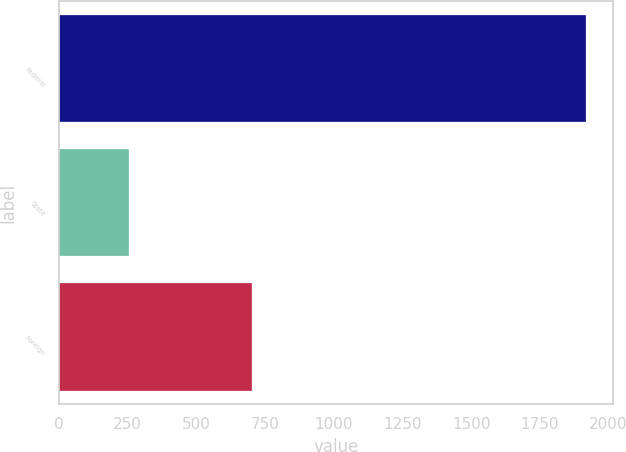Convert chart to OTSL. <chart><loc_0><loc_0><loc_500><loc_500><bar_chart><fcel>Federal<fcel>State<fcel>Foreign<nl><fcel>1919<fcel>256<fcel>704<nl></chart> 